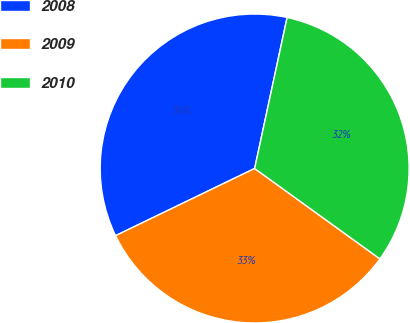Convert chart. <chart><loc_0><loc_0><loc_500><loc_500><pie_chart><fcel>2008<fcel>2009<fcel>2010<nl><fcel>35.53%<fcel>32.89%<fcel>31.58%<nl></chart> 